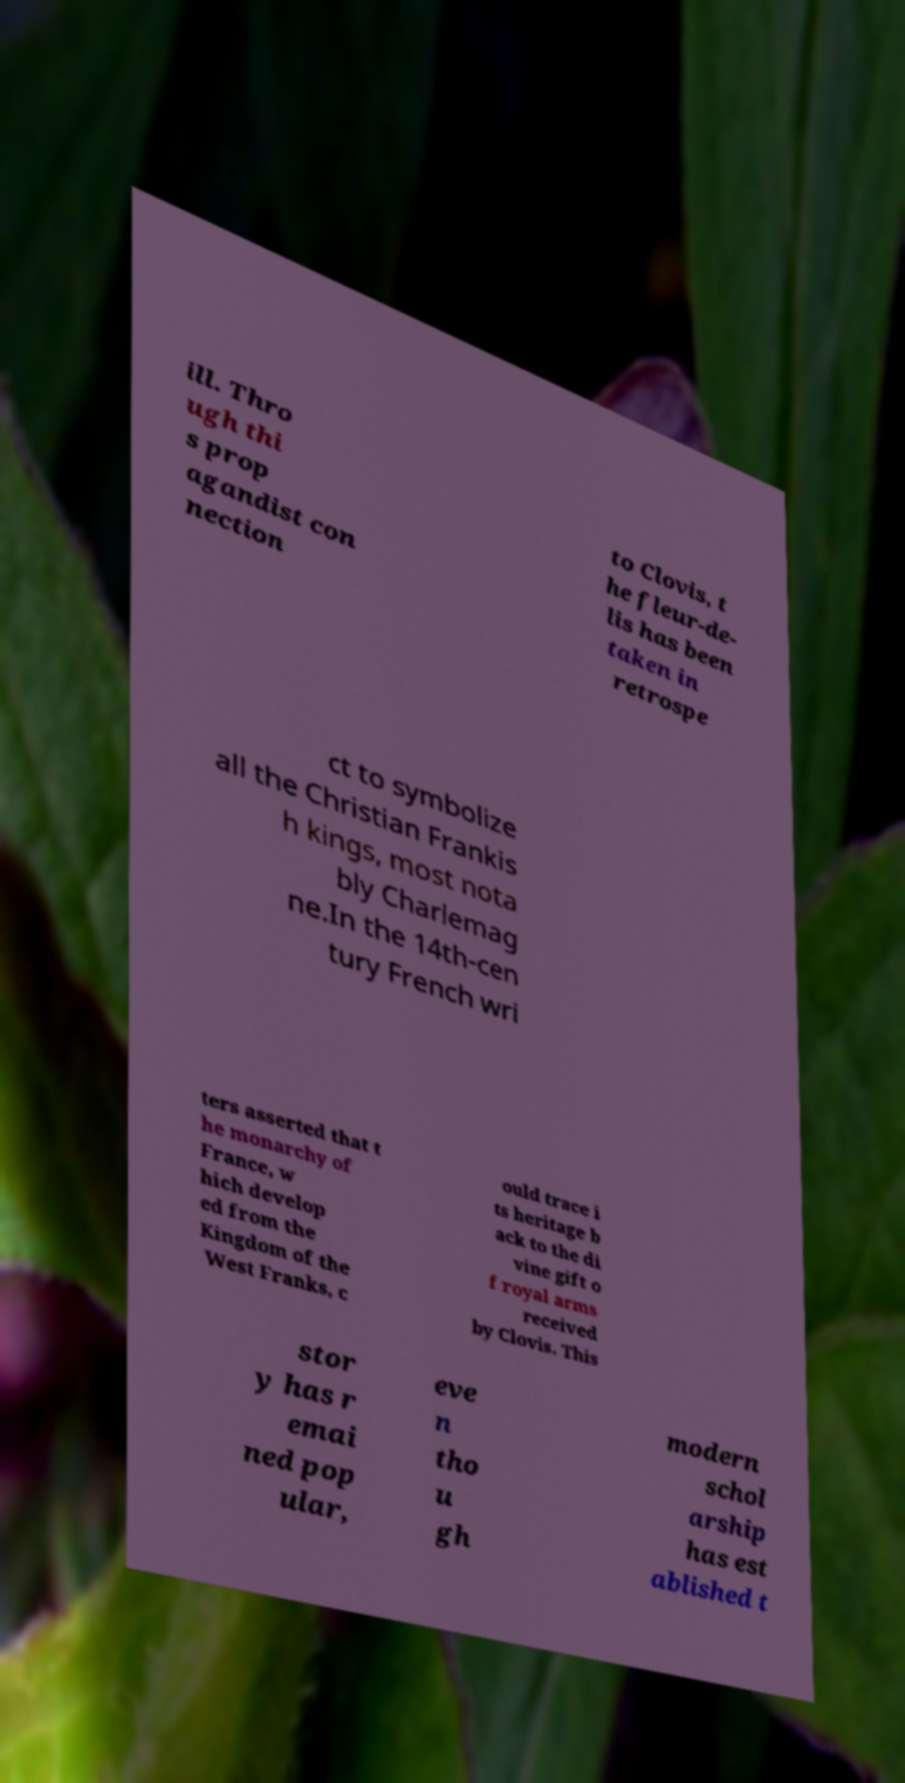For documentation purposes, I need the text within this image transcribed. Could you provide that? ill. Thro ugh thi s prop agandist con nection to Clovis, t he fleur-de- lis has been taken in retrospe ct to symbolize all the Christian Frankis h kings, most nota bly Charlemag ne.In the 14th-cen tury French wri ters asserted that t he monarchy of France, w hich develop ed from the Kingdom of the West Franks, c ould trace i ts heritage b ack to the di vine gift o f royal arms received by Clovis. This stor y has r emai ned pop ular, eve n tho u gh modern schol arship has est ablished t 